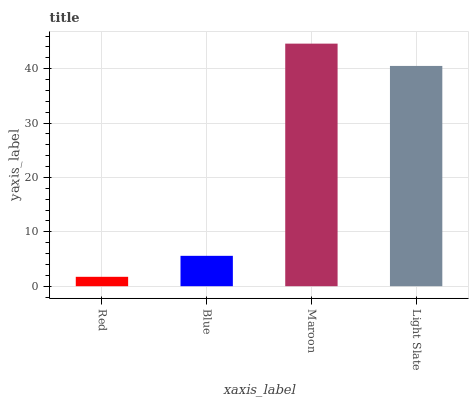Is Red the minimum?
Answer yes or no. Yes. Is Maroon the maximum?
Answer yes or no. Yes. Is Blue the minimum?
Answer yes or no. No. Is Blue the maximum?
Answer yes or no. No. Is Blue greater than Red?
Answer yes or no. Yes. Is Red less than Blue?
Answer yes or no. Yes. Is Red greater than Blue?
Answer yes or no. No. Is Blue less than Red?
Answer yes or no. No. Is Light Slate the high median?
Answer yes or no. Yes. Is Blue the low median?
Answer yes or no. Yes. Is Red the high median?
Answer yes or no. No. Is Maroon the low median?
Answer yes or no. No. 